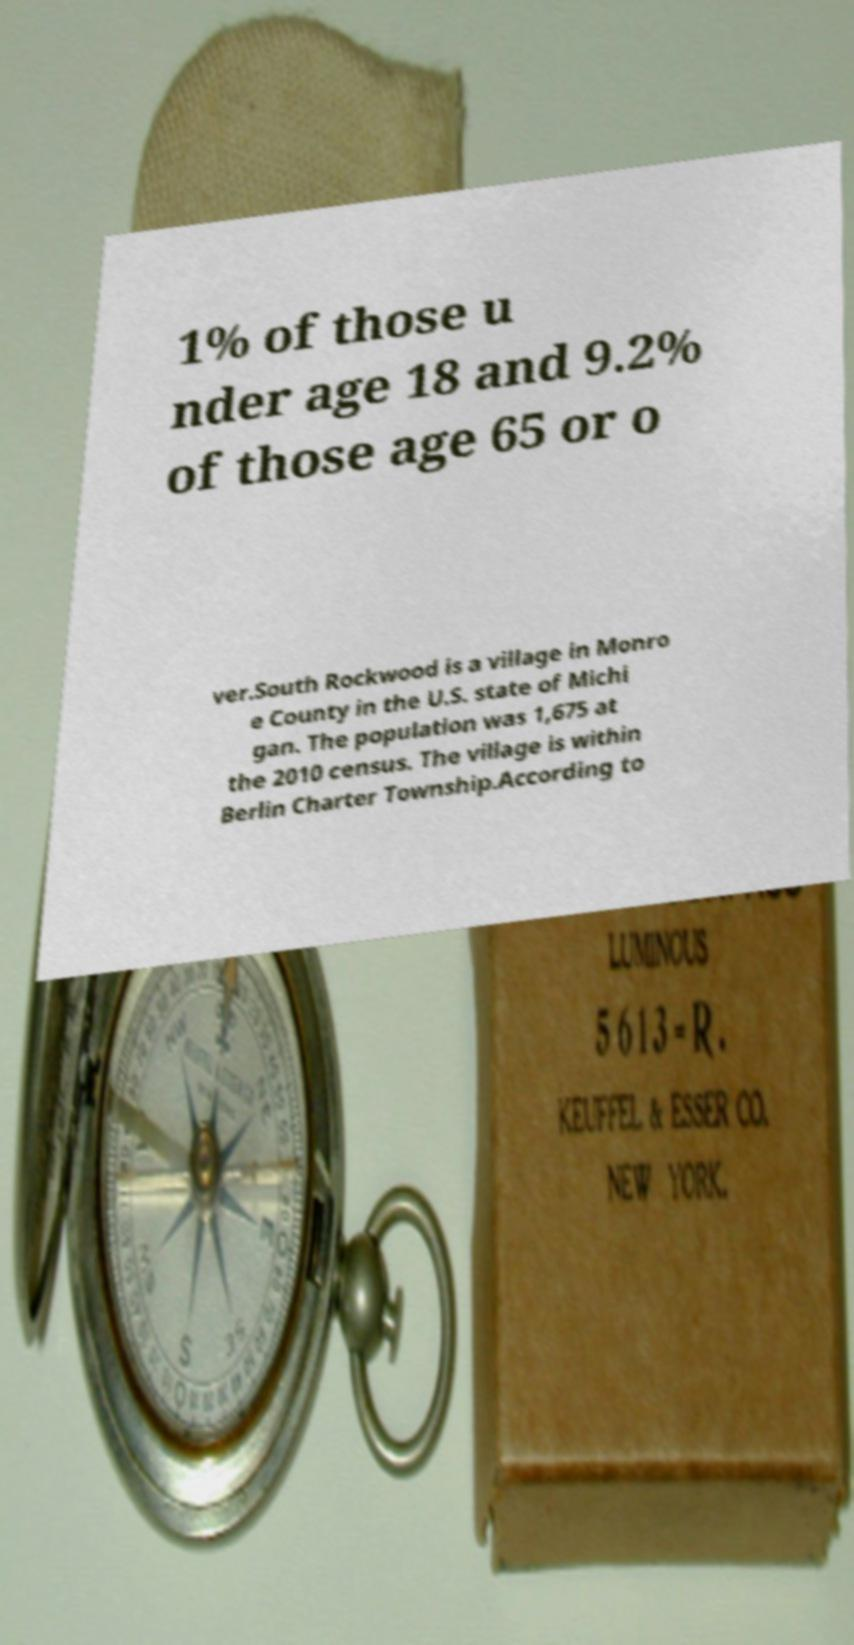Could you extract and type out the text from this image? 1% of those u nder age 18 and 9.2% of those age 65 or o ver.South Rockwood is a village in Monro e County in the U.S. state of Michi gan. The population was 1,675 at the 2010 census. The village is within Berlin Charter Township.According to 